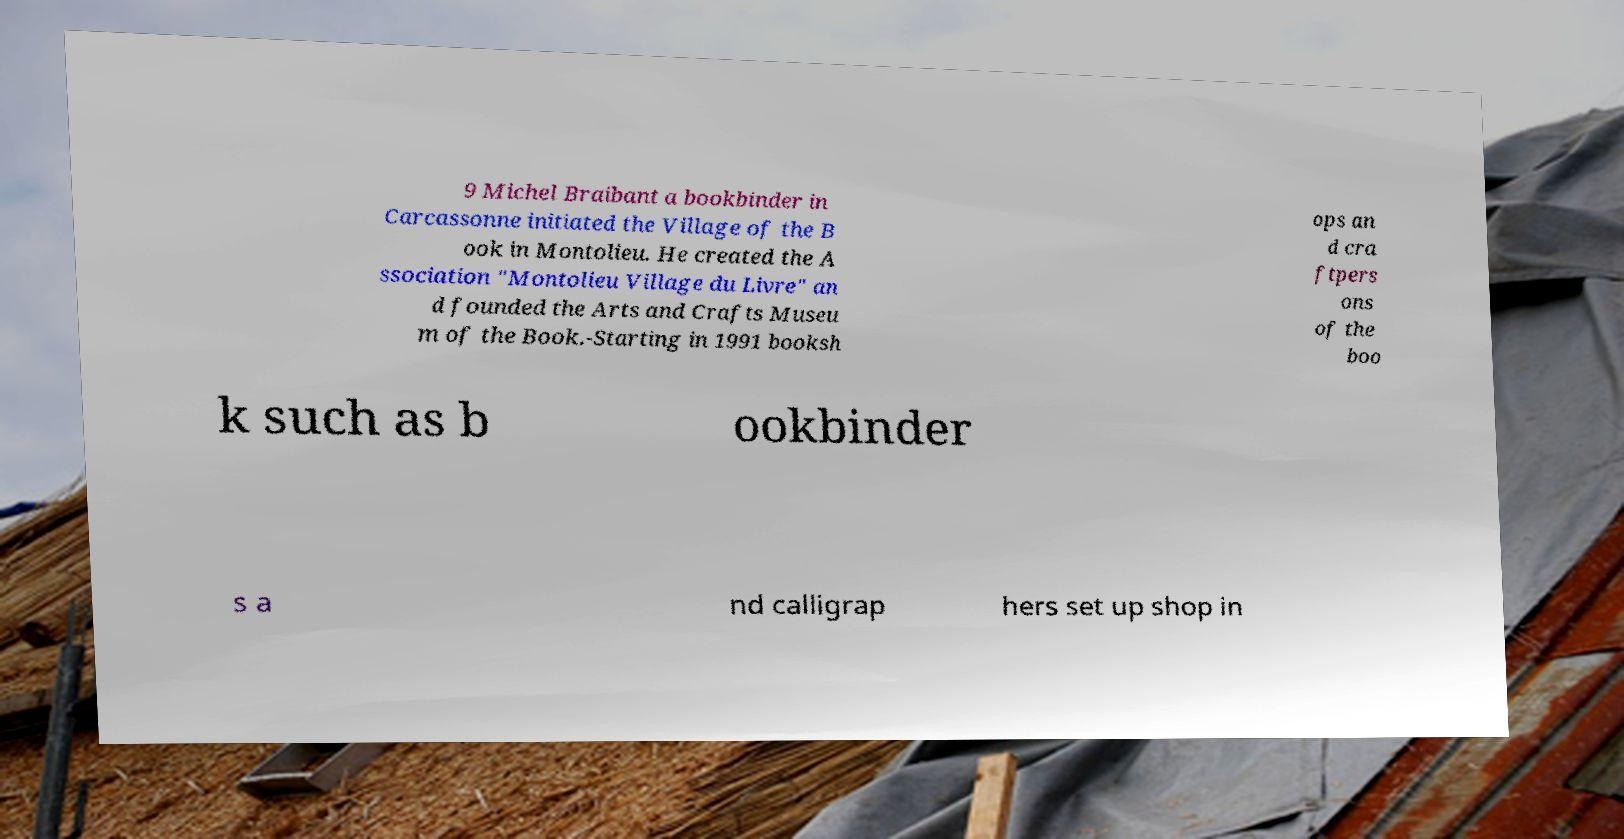I need the written content from this picture converted into text. Can you do that? 9 Michel Braibant a bookbinder in Carcassonne initiated the Village of the B ook in Montolieu. He created the A ssociation "Montolieu Village du Livre" an d founded the Arts and Crafts Museu m of the Book.-Starting in 1991 booksh ops an d cra ftpers ons of the boo k such as b ookbinder s a nd calligrap hers set up shop in 